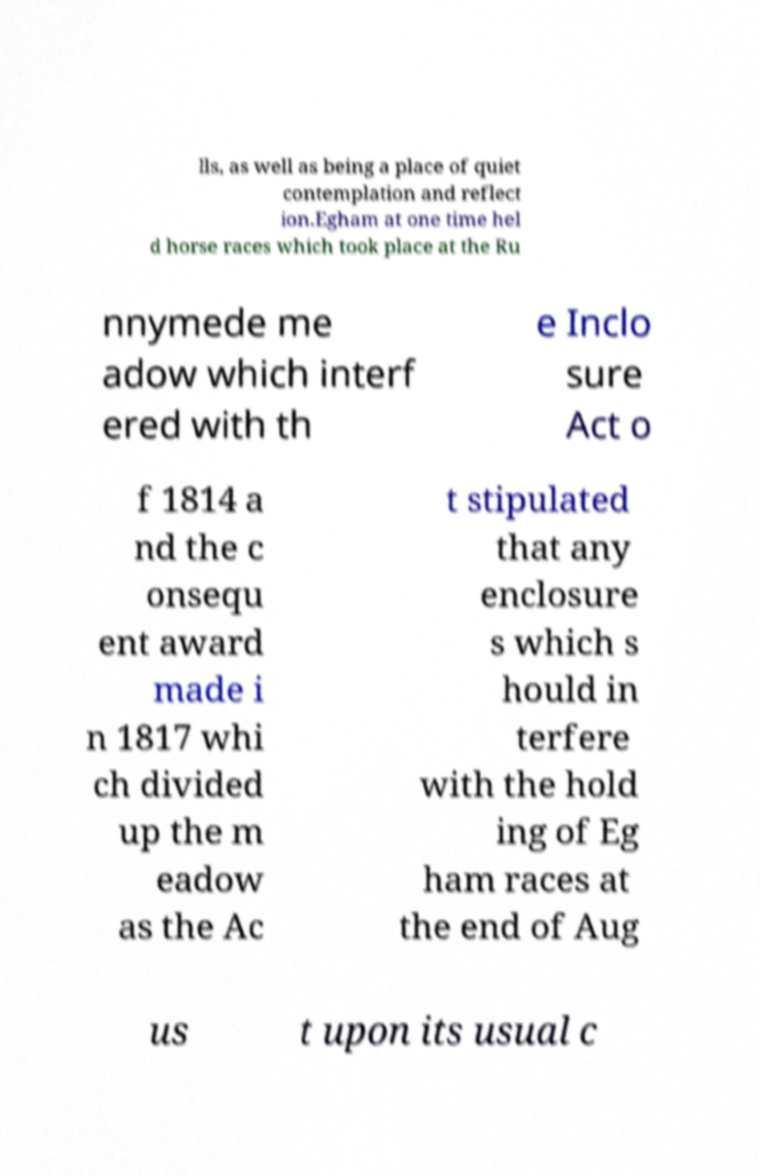Please read and relay the text visible in this image. What does it say? lls, as well as being a place of quiet contemplation and reflect ion.Egham at one time hel d horse races which took place at the Ru nnymede me adow which interf ered with th e Inclo sure Act o f 1814 a nd the c onsequ ent award made i n 1817 whi ch divided up the m eadow as the Ac t stipulated that any enclosure s which s hould in terfere with the hold ing of Eg ham races at the end of Aug us t upon its usual c 